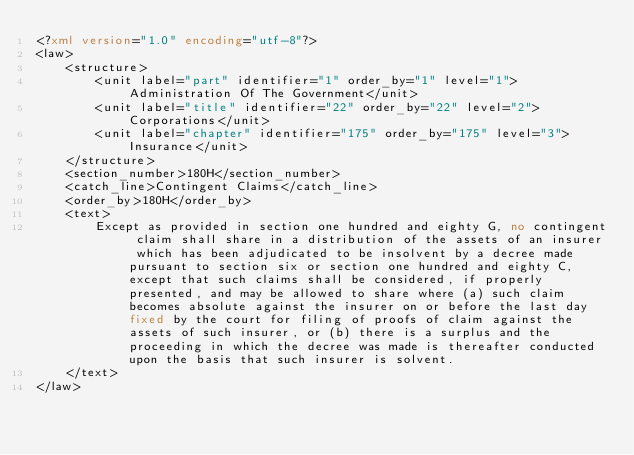Convert code to text. <code><loc_0><loc_0><loc_500><loc_500><_XML_><?xml version="1.0" encoding="utf-8"?>
<law>
    <structure>
        <unit label="part" identifier="1" order_by="1" level="1">Administration Of The Government</unit>
        <unit label="title" identifier="22" order_by="22" level="2">Corporations</unit>
        <unit label="chapter" identifier="175" order_by="175" level="3">Insurance</unit>
    </structure>
    <section_number>180H</section_number>
    <catch_line>Contingent Claims</catch_line>
    <order_by>180H</order_by>
    <text>
        Except as provided in section one hundred and eighty G, no contingent claim shall share in a distribution of the assets of an insurer which has been adjudicated to be insolvent by a decree made pursuant to section six or section one hundred and eighty C, except that such claims shall be considered, if properly presented, and may be allowed to share where (a) such claim becomes absolute against the insurer on or before the last day fixed by the court for filing of proofs of claim against the assets of such insurer, or (b) there is a surplus and the proceeding in which the decree was made is thereafter conducted upon the basis that such insurer is solvent.
    </text>
</law></code> 